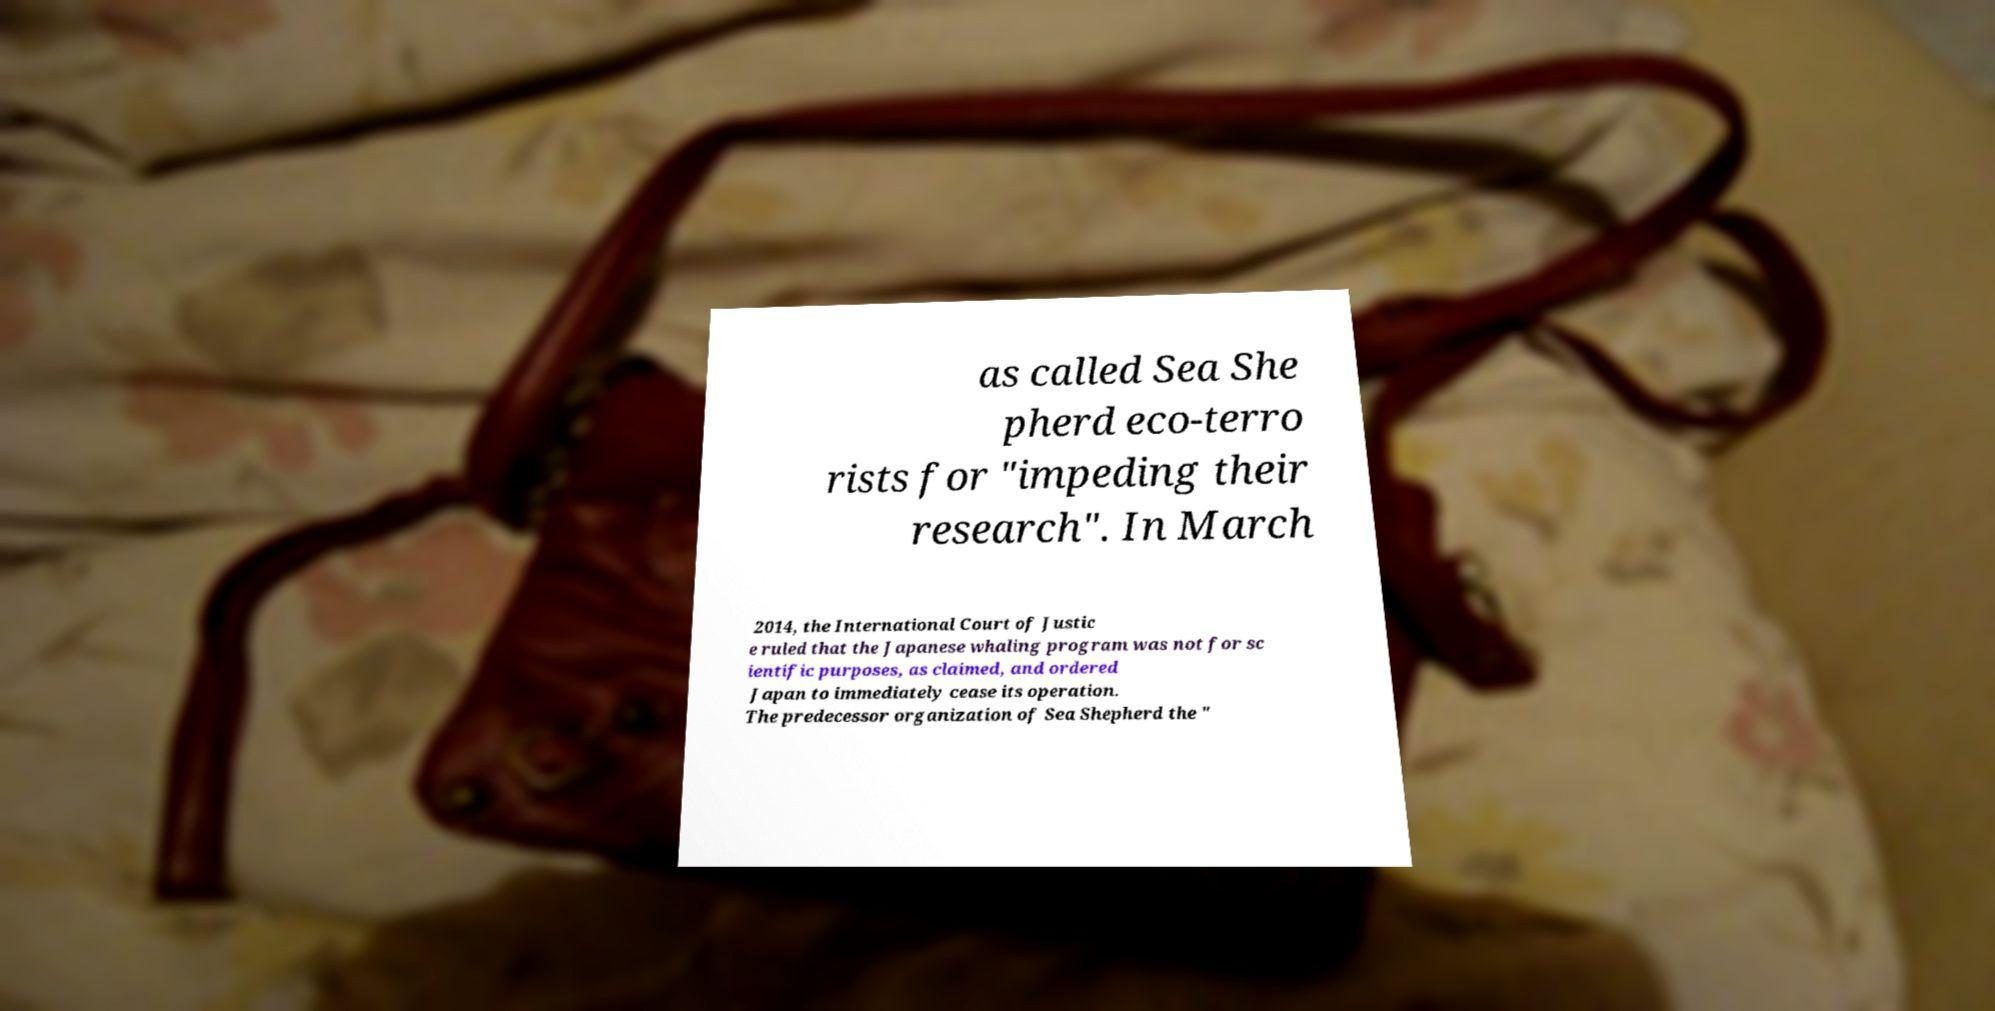What messages or text are displayed in this image? I need them in a readable, typed format. as called Sea She pherd eco-terro rists for "impeding their research". In March 2014, the International Court of Justic e ruled that the Japanese whaling program was not for sc ientific purposes, as claimed, and ordered Japan to immediately cease its operation. The predecessor organization of Sea Shepherd the " 